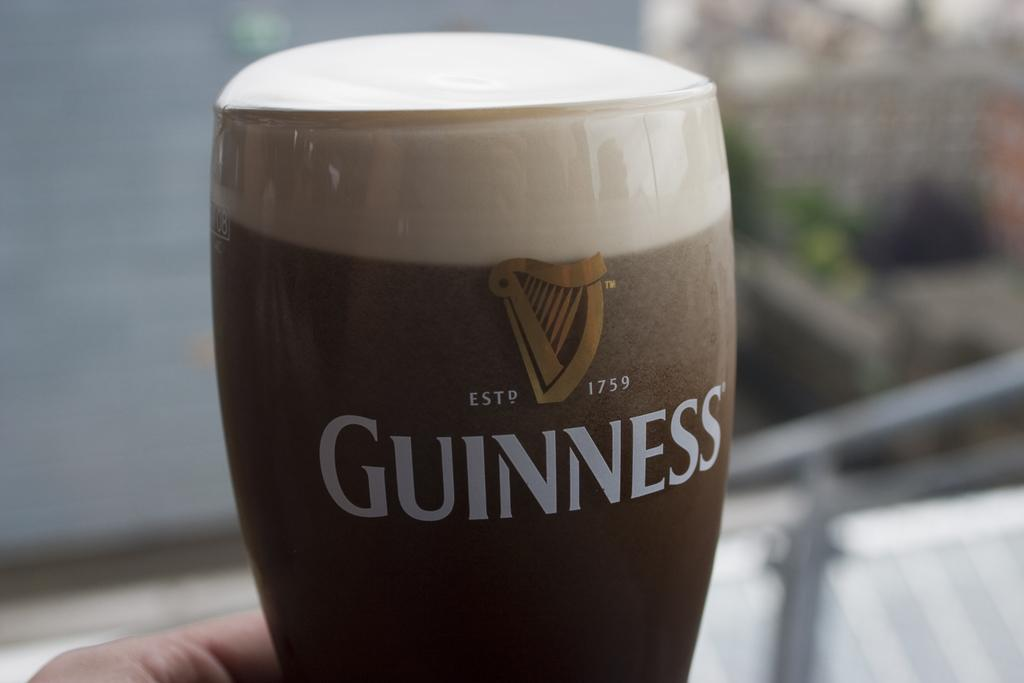<image>
Create a compact narrative representing the image presented. A glass advertising the brand of Guinness with foam at the top 